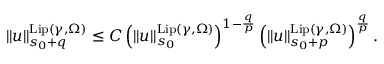<formula> <loc_0><loc_0><loc_500><loc_500>\begin{array} { r } { \| u \| _ { s _ { 0 } + q } ^ { L i p ( \gamma , \Omega ) } \leq C \left ( \| u \| _ { s _ { 0 } } ^ { L i p ( \gamma , \Omega ) } \right ) ^ { 1 - \frac { q } p } \left ( \| u \| _ { s _ { 0 } + p } ^ { L i p ( \gamma , \Omega ) } \right ) ^ { \frac { q } { p } } . } \end{array}</formula> 